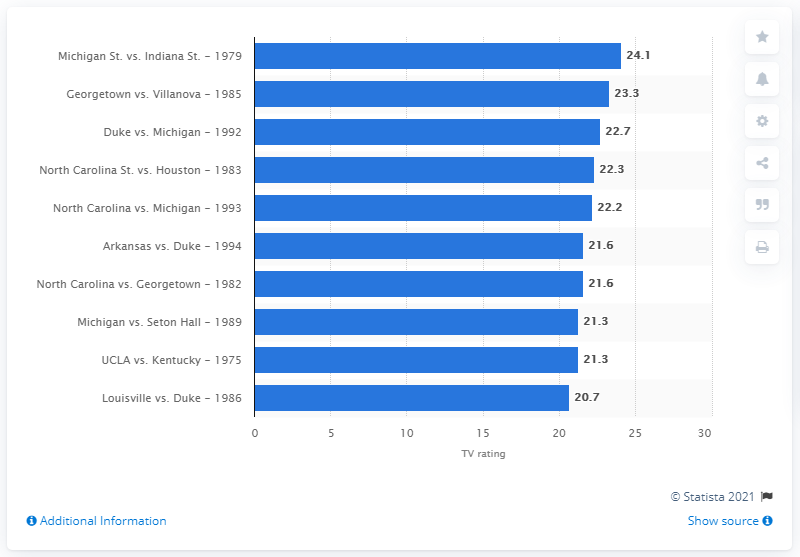Outline some significant characteristics in this image. The national championship game between Michigan State and Indiana State in 1979 was rated with a score of 24.1. 